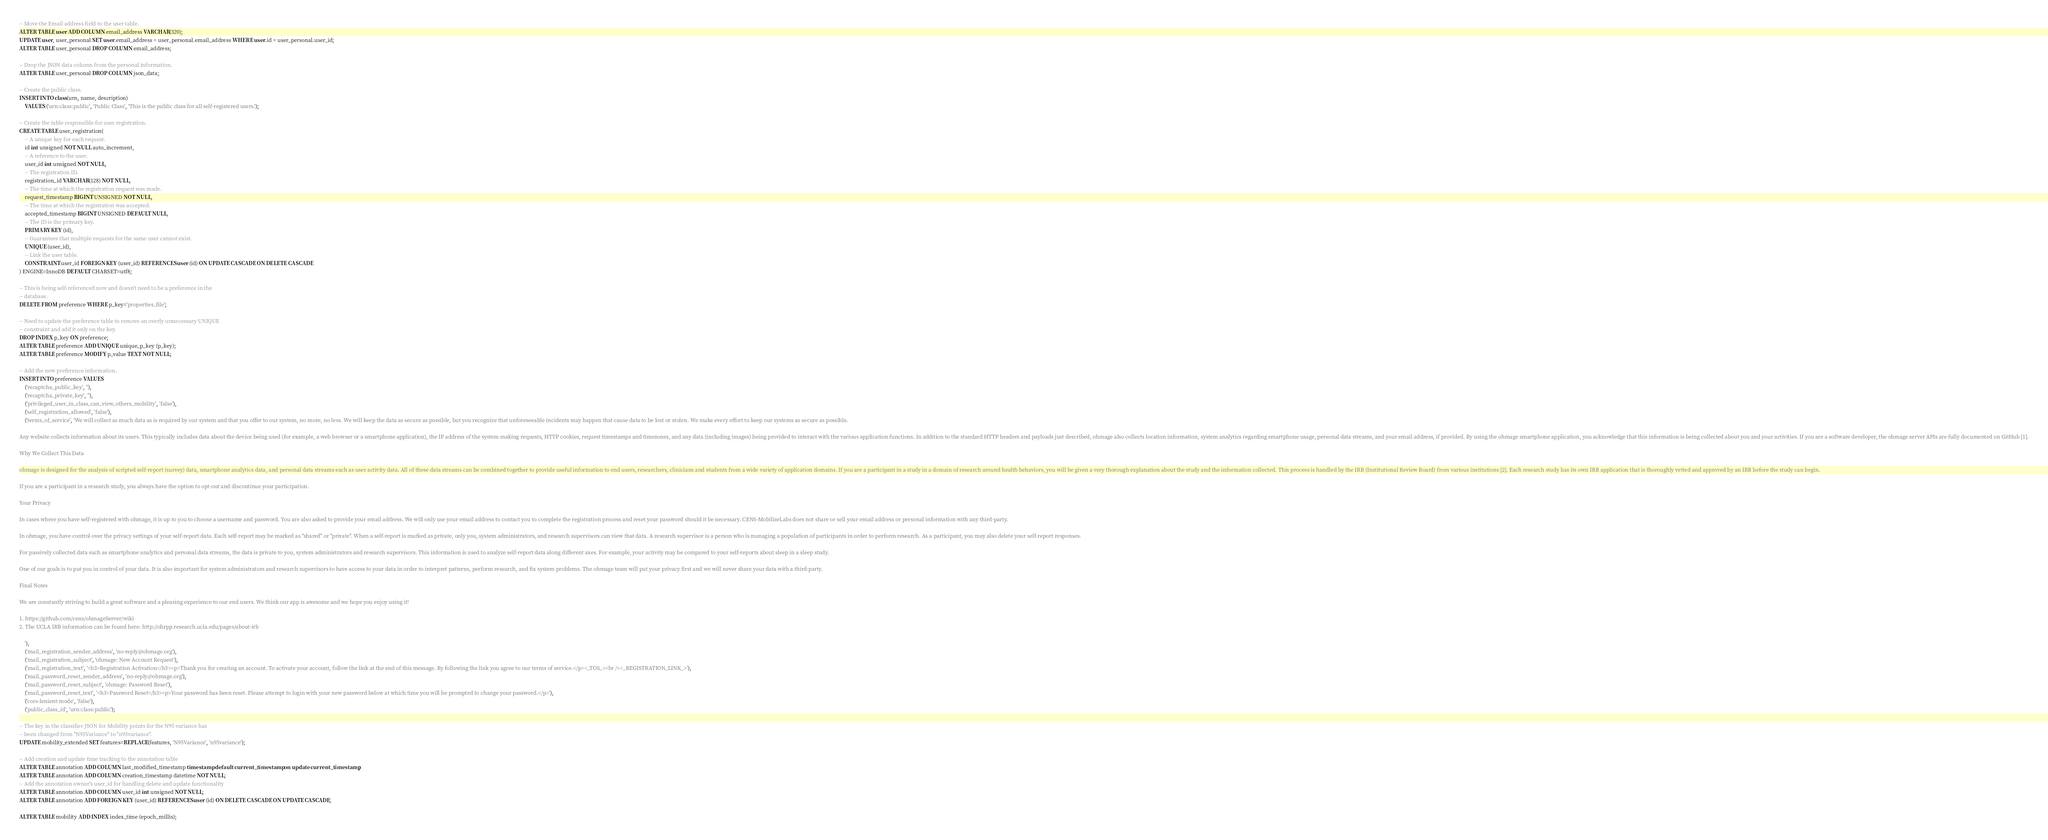Convert code to text. <code><loc_0><loc_0><loc_500><loc_500><_SQL_>-- Move the Email address field to the user table.
ALTER TABLE user ADD COLUMN email_address VARCHAR(320);
UPDATE user, user_personal SET user.email_address = user_personal.email_address WHERE user.id = user_personal.user_id;
ALTER TABLE user_personal DROP COLUMN email_address;

-- Drop the JSON data column from the personal information.
ALTER TABLE user_personal DROP COLUMN json_data;

-- Create the public class.
INSERT INTO class(urn, name, description)
    VALUES ('urn:class:public', 'Public Class', 'This is the public class for all self-registered users.');

-- Create the table responsible for user registration.
CREATE TABLE user_registration(
    -- A unique key for each request.
    id int unsigned NOT NULL auto_increment,
    -- A reference to the user.
    user_id int unsigned NOT NULL,
    -- The registration ID.
    registration_id VARCHAR(128) NOT NULL,
    -- The time at which the registration request was made.
    request_timestamp BIGINT UNSIGNED NOT NULL,
    -- The time at which the registration was accepted.
    accepted_timestamp BIGINT UNSIGNED DEFAULT NULL,
    -- The ID is the primary key.
    PRIMARY KEY (id),
    -- Guarantees that multiple requests for the same user cannot exist.
    UNIQUE (user_id),
    -- Link the user table.
    CONSTRAINT user_id FOREIGN KEY (user_id) REFERENCES user (id) ON UPDATE CASCADE ON DELETE CASCADE
) ENGINE=InnoDB DEFAULT CHARSET=utf8;

-- This is being self-referenced now and doesn't need to be a preference in the
-- database.
DELETE FROM preference WHERE p_key='properties_file';

-- Need to update the preference table to remove an overly unnecessary UNIQUE 
-- constraint and add it only on the key.
DROP INDEX p_key ON preference;
ALTER TABLE preference ADD UNIQUE unique_p_key (p_key);
ALTER TABLE preference MODIFY p_value TEXT NOT NULL;

-- Add the new preference information.
INSERT INTO preference VALUES 
    ('recaptcha_public_key', ''),
    ('recaptcha_private_key', ''),
    ('privileged_user_in_class_can_view_others_mobility', 'false'),
    ('self_registration_allowed', 'false'),
    ('terms_of_service', 'We will collect as much data as is required by our system and that you offer to our system, no more, no less. We will keep the data as secure as possible, but you recognize that unforeseeable incidents may happen that cause data to be lost or stolen. We make every effort to keep our systems as secure as possible.

Any website collects information about its users. This typically includes data about the device being used (for example, a web browser or a smartphone application), the IP address of the system making requests, HTTP cookies, request timestamps and timezones, and any data (including images) being provided to interact with the various application functions. In addition to the standard HTTP headers and payloads just described, ohmage also collects location information, system analytics regarding smartphone usage, personal data streams, and your email address, if provided. By using the ohmage smartphone application, you acknowledge that this information is being collected about you and your activities. If you are a software developer, the ohmage server APIs are fully documented on GitHub [1].

Why We Collect This Data

ohmage is designed for the analysis of scripted self-report (survey) data, smartphone analytics data, and personal data streams such as user activity data. All of these data streams can be combined together to provide useful information to end users, researchers, clinicians and students from a wide variety of application domains. If you are a participant in a study in a domain of research around health behaviors, you will be given a very thorough explanation about the study and the information collected. This process is handled by the IRB (Institutional Review Board) from various institutions [2]. Each research study has its own IRB application that is thoroughly vetted and approved by an IRB before the study can begin.

If you are a participant in a research study, you always have the option to opt-out and discontinue your participation.

Your Privacy

In cases where you have self-registered with ohmage, it is up to you to choose a username and password. You are also asked to provide your email address. We will only use your email address to contact you to complete the registration process and reset your password should it be necessary. CENS-MobilizeLabs does not share or sell your email address or personal information with any third-party.

In ohmage, you have control over the privacy settings of your self-report data. Each self-report may be marked as "shared" or "private". When a self-report is marked as private, only you, system administrators, and research supervisors can view that data. A research supervisor is a person who is managing a population of participants in order to perform research. As a participant, you may also delete your self-report responses.

For passively collected data such as smartphone analytics and personal data streams, the data is private to you, system administrators and research supervisors. This information is used to analyze self-report data along different axes. For example, your activity may be compared to your self-reports about sleep in a sleep study.

One of our goals is to put you in control of your data. It is also important for system administrators and research supervisors to have access to your data in order to interpret patterns, perform research, and fix system problems. The ohmage team will put your privacy first and we will never share your data with a third-party.

Final Notes

We are constantly striving to build a great software and a pleasing experience to our end users. We think our app is awesome and we hope you enjoy using it!

1. https://github.com/cens/ohmageServer/wiki
2. The UCLA IRB information can be found here: http://ohrpp.research.ucla.edu/pages/about-irb

    '),
    ('mail_registration_sender_address', 'no-reply@ohmage.org'),
    ('mail_registration_subject', 'ohmage: New Account Request'),
    ('mail_registration_text', '<h3>Registration Activation</h3><p>Thank you for creating an account. To activate your account, follow the link at the end of this message. By following the link you agree to our terms of service.</p><_TOS_><br /><_REGISTRATION_LINK_>'),
    ('mail_password_reset_sender_address', 'no-reply@ohmage.org'),
    ('mail_password_reset_subject', 'ohmage: Password Reset'),
    ('mail_password_reset_text', '<h3>Password Reset</h3><p>Your password has been reset. Please attempt to login with your new password below at which time you will be prompted to change your password.</p>'),
    ('cors-lenient-mode', 'false'),
    ('public_class_id', 'urn:class:public');
    
-- The key in the classifier JSON for Mobility points for the N95 variance has
-- been changed from "N95Variance" to "n95variance".
UPDATE mobility_extended SET features=REPLACE(features, 'N95Variance', 'n95variance');

-- Add creation and update time tracking to the annotation table
ALTER TABLE annotation ADD COLUMN last_modified_timestamp timestamp default current_timestamp on update current_timestamp;
ALTER TABLE annotation ADD COLUMN creation_timestamp datetime NOT NULL;
-- Add the annotation owner's user_id for handling delete and update functionality
ALTER TABLE annotation ADD COLUMN user_id int unsigned NOT NULL;
ALTER TABLE annotation ADD FOREIGN KEY (user_id) REFERENCES user (id) ON DELETE CASCADE ON UPDATE CASCADE;

ALTER TABLE mobility ADD INDEX index_time (epoch_millis);</code> 